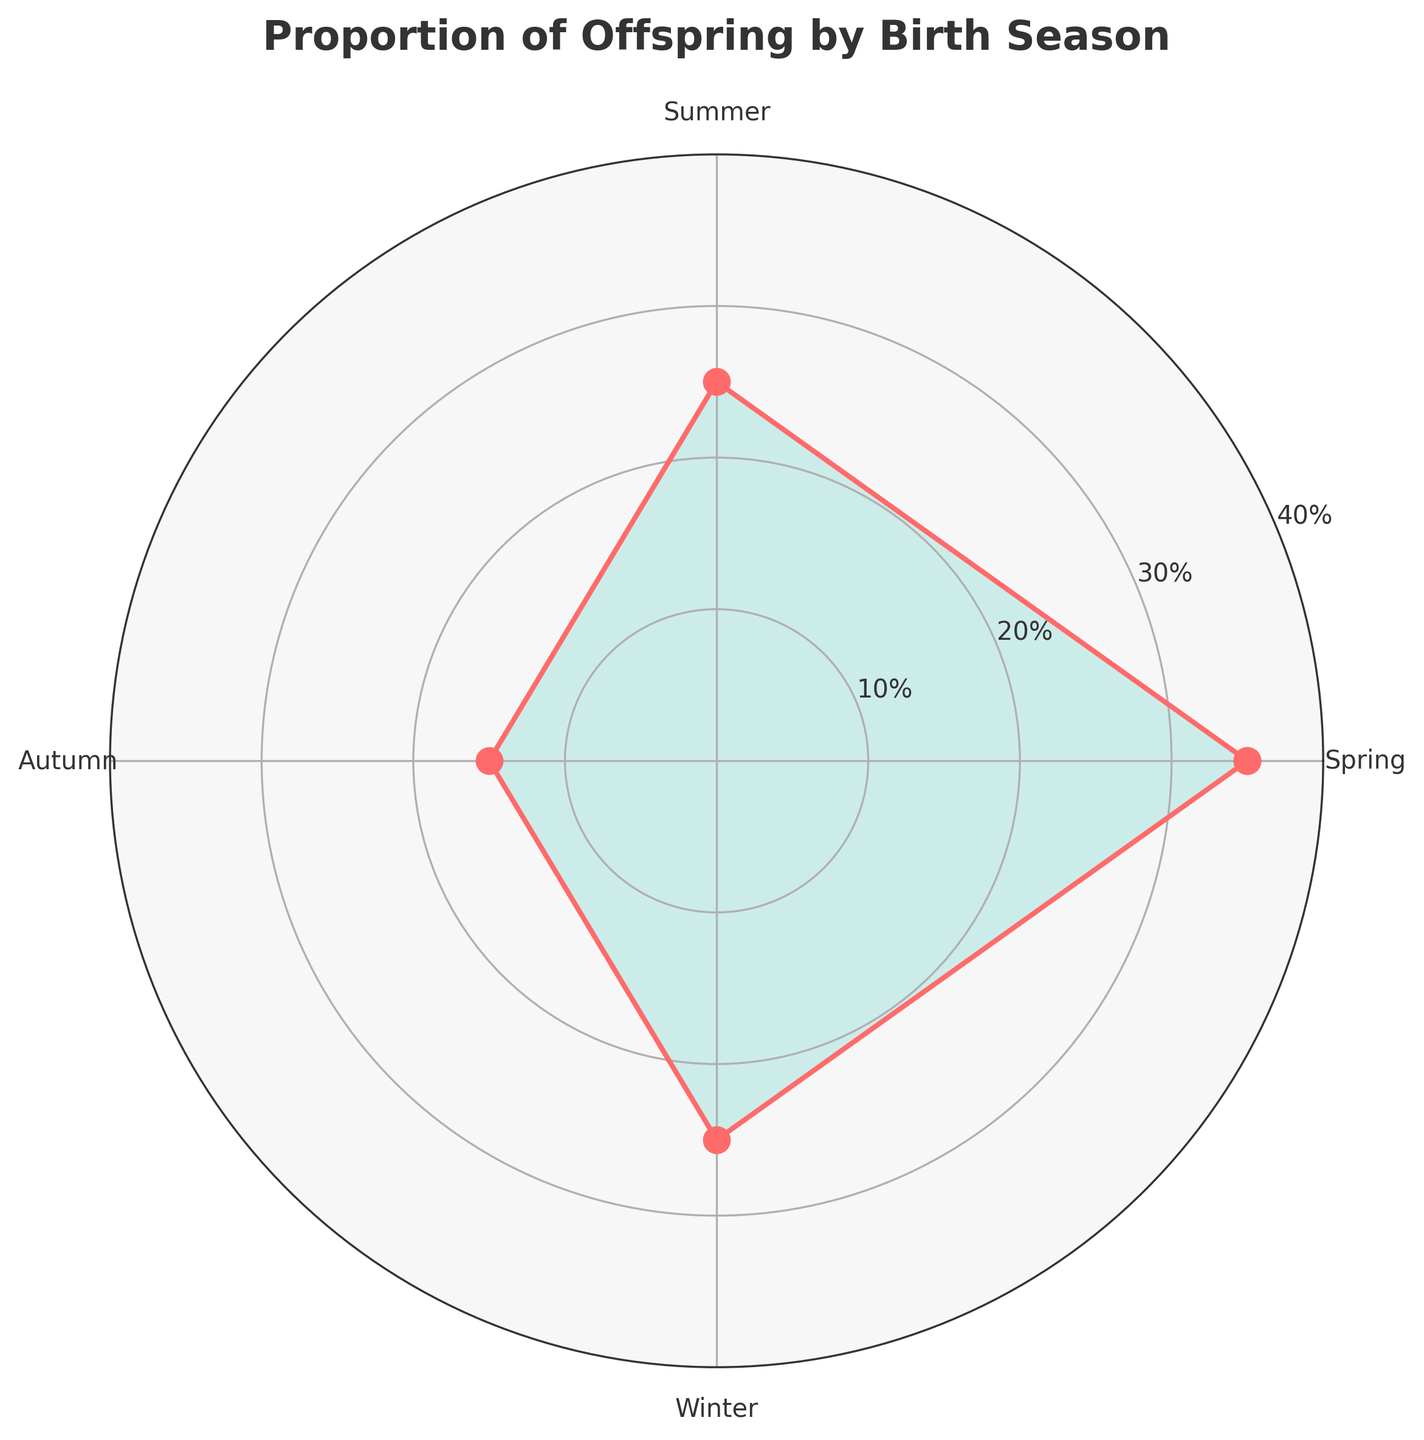What is the title of the figure? The title of the figure is located at the top and reads 'Proportion of Offspring by Birth Season'.
Answer: Proportion of Offspring by Birth Season Which season has the highest proportion of offspring? The highest proportion occurs where the curve has the greatest distance from the center, which is in Spring.
Answer: Spring How many seasons are represented in the figure? Each season is a distinct category marked in the plot. Counting them gives Spring, Summer, Autumn, Winter, making four seasons.
Answer: 4 What is the proportion of offspring born in Winter? The figure shows the proportion is 0.25 for Winter, positioned at the correct angle within the chart.
Answer: 0.25 Compare the proportion of offspring between Spring and Autumn. Spring has a value of 0.35, and Autumn has 0.15, making Spring's proportion higher.
Answer: Spring What is the sum of proportions for Summer and Winter? Summer is 0.25 and Winter is 0.25; summing them gives 0.25 + 0.25 = 0.50.
Answer: 0.50 Which seasons have the same proportion of offspring? By comparing the data points, Winter and Summer both have proportions of 0.25.
Answer: Winter and Summer What is the difference in proportion of offspring between Spring and Summer? Spring has a proportion of 0.35, and Summer has 0.25; the difference is 0.35 - 0.25 = 0.10.
Answer: 0.10 What is the average proportion of offspring across all seasons? Sum all proportions (0.35 + 0.25 + 0.15 + 0.25 = 1.00) and divide by the number of seasons (4), getting 1.00 / 4 = 0.25.
Answer: 0.25 